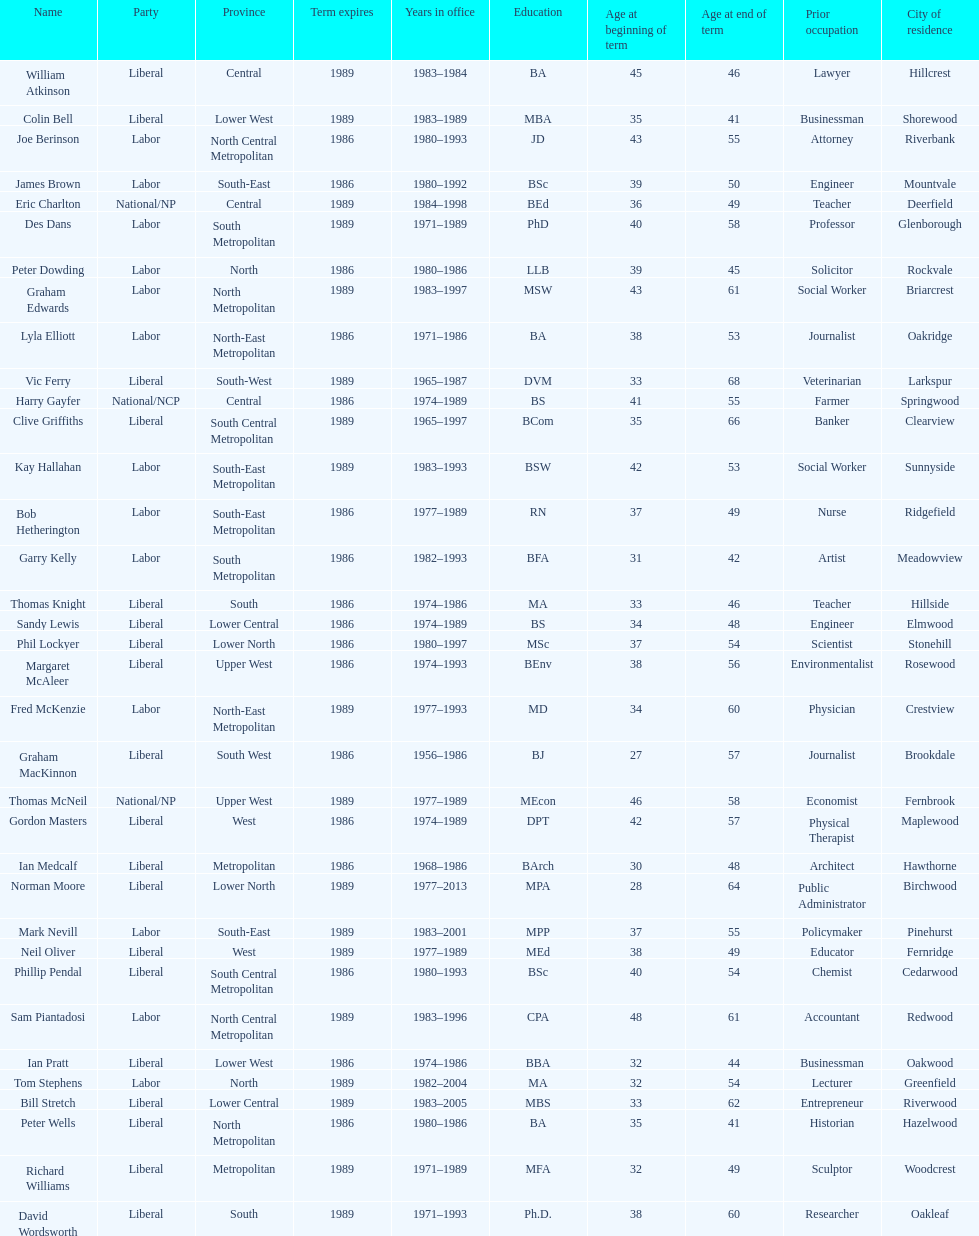How many members were party of lower west province? 2. 